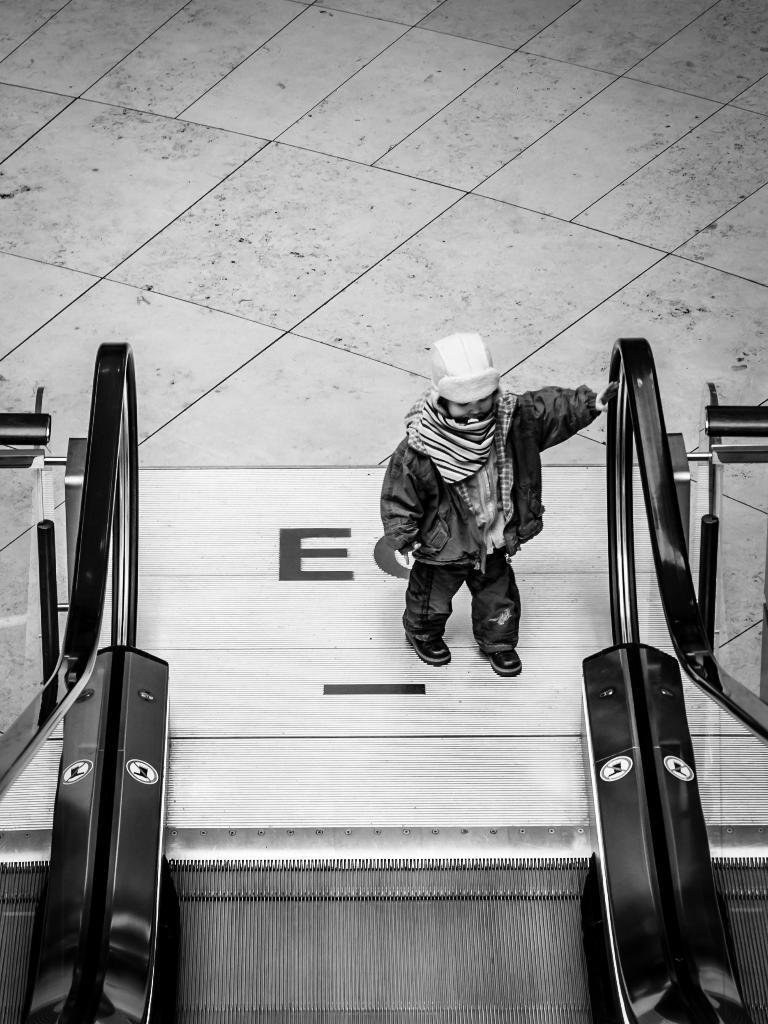In one or two sentences, can you explain what this image depicts? In this picture I can see an escalator, a human standing and he is wearing a cap. I can see floor in the background. 